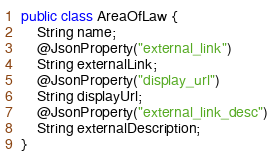Convert code to text. <code><loc_0><loc_0><loc_500><loc_500><_Java_>public class AreaOfLaw {
    String name;
    @JsonProperty("external_link")
    String externalLink;
    @JsonProperty("display_url")
    String displayUrl;
    @JsonProperty("external_link_desc")
    String externalDescription;
}
</code> 